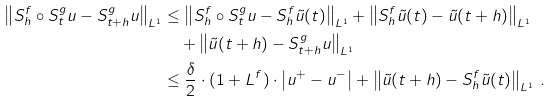Convert formula to latex. <formula><loc_0><loc_0><loc_500><loc_500>\left \| S _ { h } ^ { f } \circ S ^ { g } _ { t } u - S ^ { g } _ { t + h } u \right \| _ { L ^ { 1 } } & \leq \left \| S _ { h } ^ { f } \circ S ^ { g } _ { t } u - S ^ { f } _ { h } \tilde { u } ( t ) \right \| _ { L ^ { 1 } } + \left \| S ^ { f } _ { h } \tilde { u } ( t ) - \tilde { u } ( t + h ) \right \| _ { L ^ { 1 } } \\ & \quad + \left \| \tilde { u } ( t + h ) - S _ { t + h } ^ { g } u \right \| _ { L ^ { 1 } } \\ & \leq \frac { \delta } { 2 } \cdot ( 1 + L ^ { f } ) \cdot \left | u ^ { + } - u ^ { - } \right | + \left \| \tilde { u } ( t + h ) - S _ { h } ^ { f } \tilde { u } ( t ) \right \| _ { L ^ { 1 } } \, .</formula> 